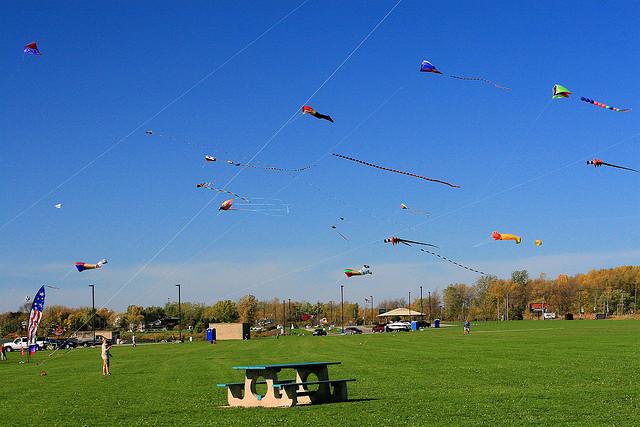What color are the cars?
Answer briefly. White. What kind of table is in the grass?
Keep it brief. Picnic. Do you see a picnic table?
Be succinct. Yes. What can you see in the sky?
Answer briefly. Kites. 